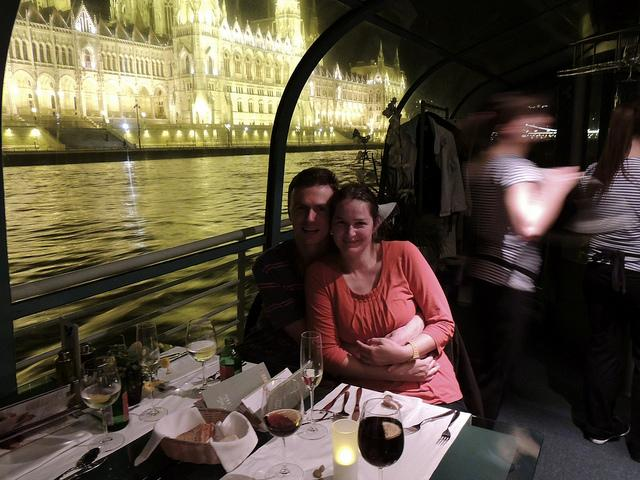Where is the couple most probably dining? boat 